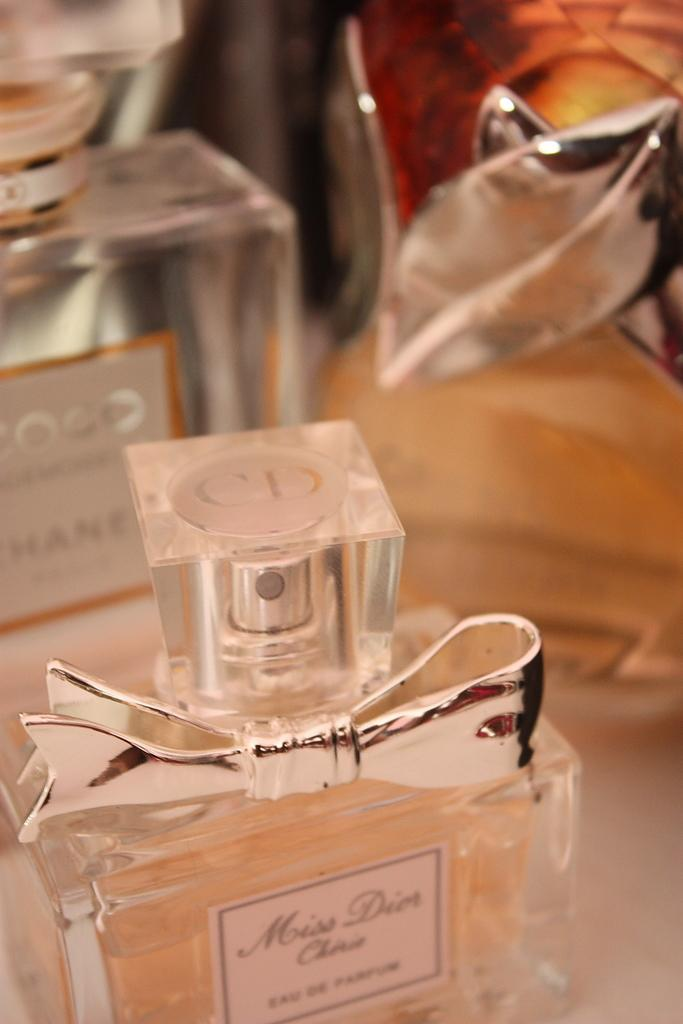<image>
Write a terse but informative summary of the picture. A bottle of perfume that says Miss Dior on it with another bottle behind it. 